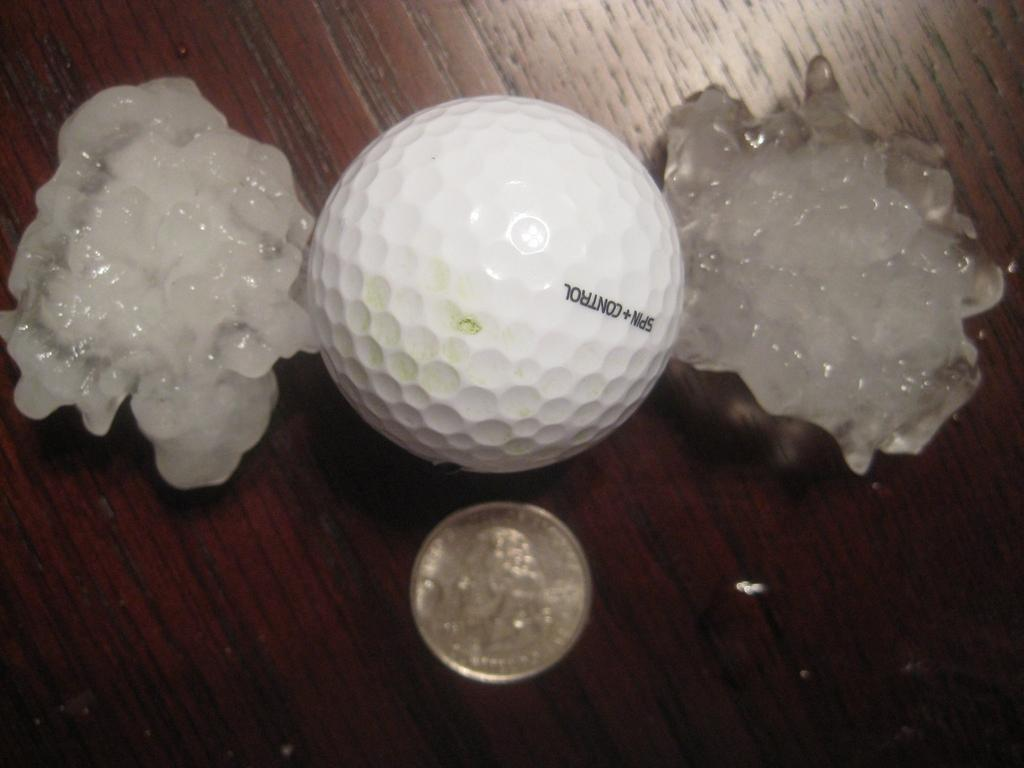What is the main object in the image? There is a golf ball in the image. What other object can be seen in the image? There is a coin in the image. Where are these objects located? They are on a wooden surface in the image. What type of grip does the golf ball have on the journey in the image? The golf ball does not have a grip, nor is it on a journey in the image; it is stationary on a wooden surface. 